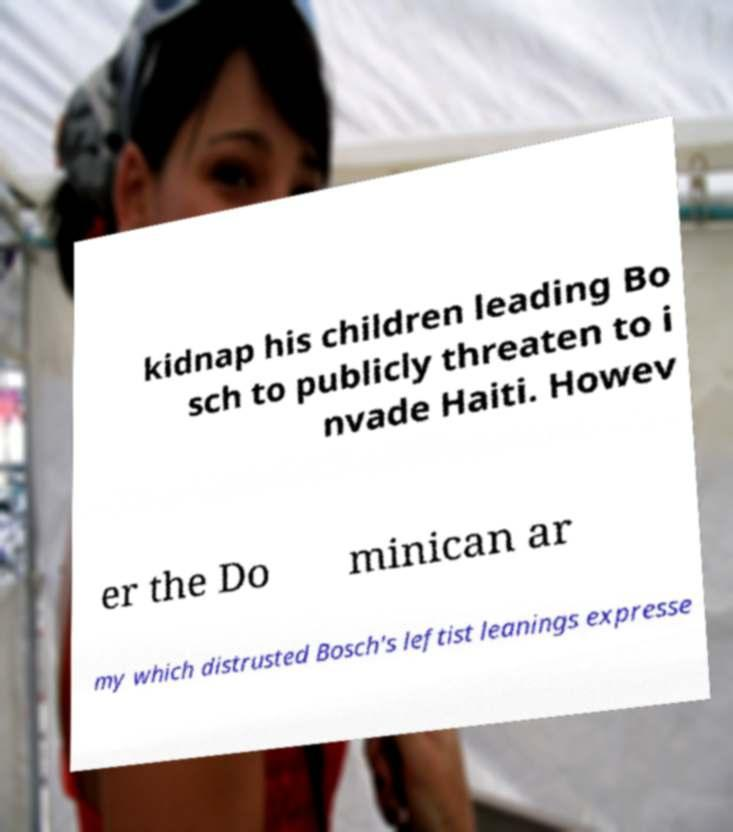Can you accurately transcribe the text from the provided image for me? kidnap his children leading Bo sch to publicly threaten to i nvade Haiti. Howev er the Do minican ar my which distrusted Bosch's leftist leanings expresse 